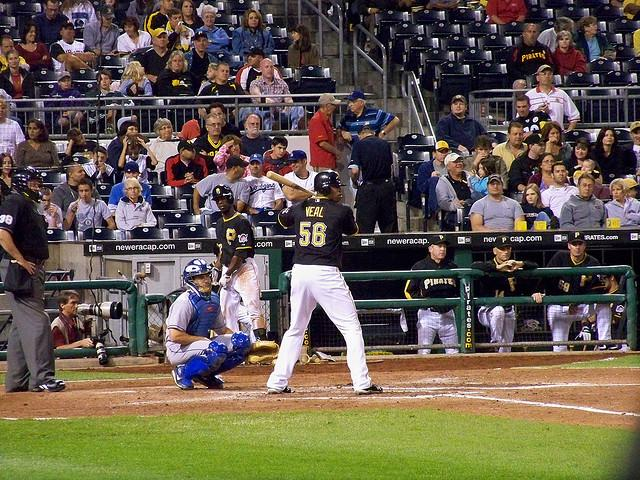What can you obtain from the website advertised?

Choices:
A) baseball bats
B) sports drinks
C) team hat
D) hubcaps team hat 